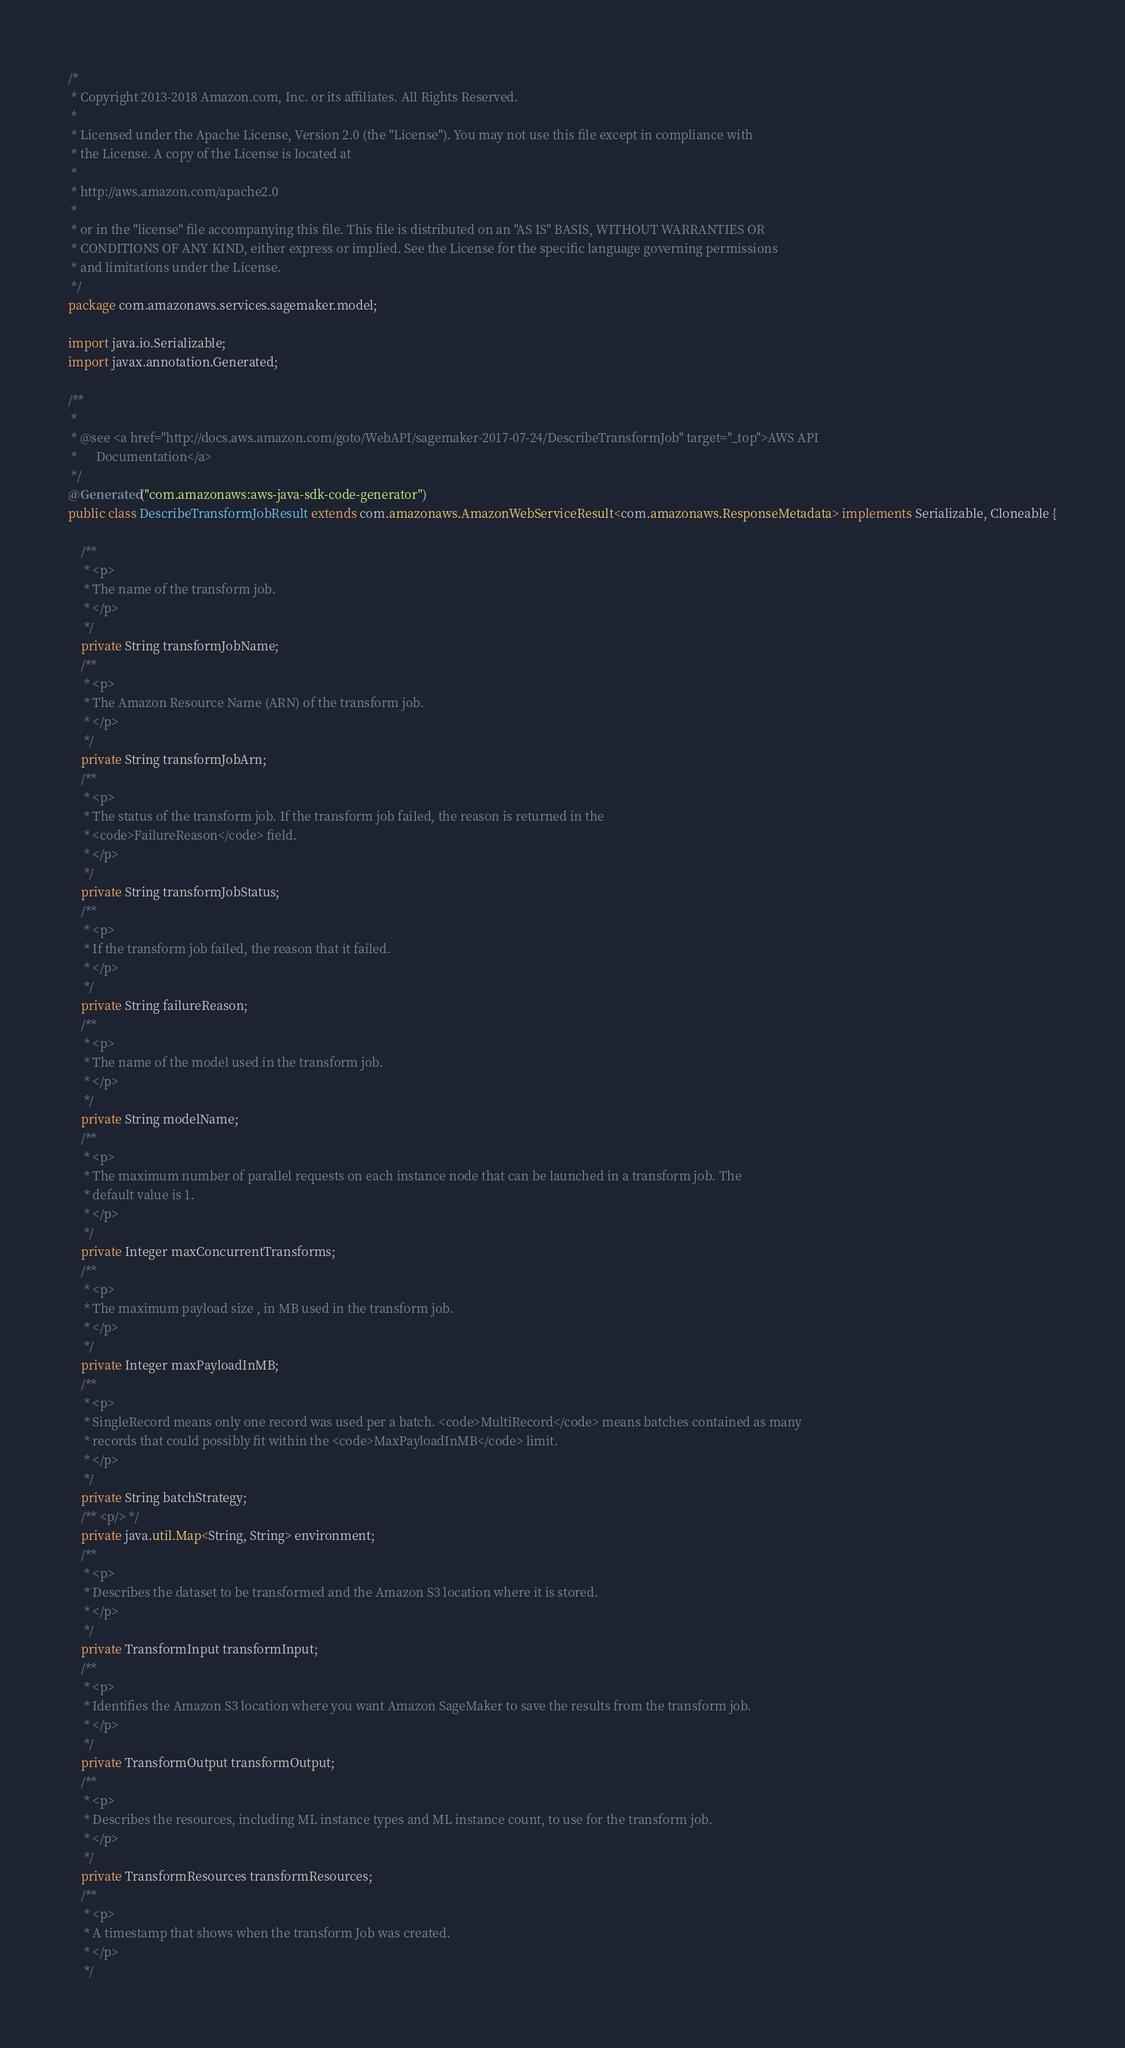<code> <loc_0><loc_0><loc_500><loc_500><_Java_>/*
 * Copyright 2013-2018 Amazon.com, Inc. or its affiliates. All Rights Reserved.
 * 
 * Licensed under the Apache License, Version 2.0 (the "License"). You may not use this file except in compliance with
 * the License. A copy of the License is located at
 * 
 * http://aws.amazon.com/apache2.0
 * 
 * or in the "license" file accompanying this file. This file is distributed on an "AS IS" BASIS, WITHOUT WARRANTIES OR
 * CONDITIONS OF ANY KIND, either express or implied. See the License for the specific language governing permissions
 * and limitations under the License.
 */
package com.amazonaws.services.sagemaker.model;

import java.io.Serializable;
import javax.annotation.Generated;

/**
 * 
 * @see <a href="http://docs.aws.amazon.com/goto/WebAPI/sagemaker-2017-07-24/DescribeTransformJob" target="_top">AWS API
 *      Documentation</a>
 */
@Generated("com.amazonaws:aws-java-sdk-code-generator")
public class DescribeTransformJobResult extends com.amazonaws.AmazonWebServiceResult<com.amazonaws.ResponseMetadata> implements Serializable, Cloneable {

    /**
     * <p>
     * The name of the transform job.
     * </p>
     */
    private String transformJobName;
    /**
     * <p>
     * The Amazon Resource Name (ARN) of the transform job.
     * </p>
     */
    private String transformJobArn;
    /**
     * <p>
     * The status of the transform job. If the transform job failed, the reason is returned in the
     * <code>FailureReason</code> field.
     * </p>
     */
    private String transformJobStatus;
    /**
     * <p>
     * If the transform job failed, the reason that it failed.
     * </p>
     */
    private String failureReason;
    /**
     * <p>
     * The name of the model used in the transform job.
     * </p>
     */
    private String modelName;
    /**
     * <p>
     * The maximum number of parallel requests on each instance node that can be launched in a transform job. The
     * default value is 1.
     * </p>
     */
    private Integer maxConcurrentTransforms;
    /**
     * <p>
     * The maximum payload size , in MB used in the transform job.
     * </p>
     */
    private Integer maxPayloadInMB;
    /**
     * <p>
     * SingleRecord means only one record was used per a batch. <code>MultiRecord</code> means batches contained as many
     * records that could possibly fit within the <code>MaxPayloadInMB</code> limit.
     * </p>
     */
    private String batchStrategy;
    /** <p/> */
    private java.util.Map<String, String> environment;
    /**
     * <p>
     * Describes the dataset to be transformed and the Amazon S3 location where it is stored.
     * </p>
     */
    private TransformInput transformInput;
    /**
     * <p>
     * Identifies the Amazon S3 location where you want Amazon SageMaker to save the results from the transform job.
     * </p>
     */
    private TransformOutput transformOutput;
    /**
     * <p>
     * Describes the resources, including ML instance types and ML instance count, to use for the transform job.
     * </p>
     */
    private TransformResources transformResources;
    /**
     * <p>
     * A timestamp that shows when the transform Job was created.
     * </p>
     */</code> 